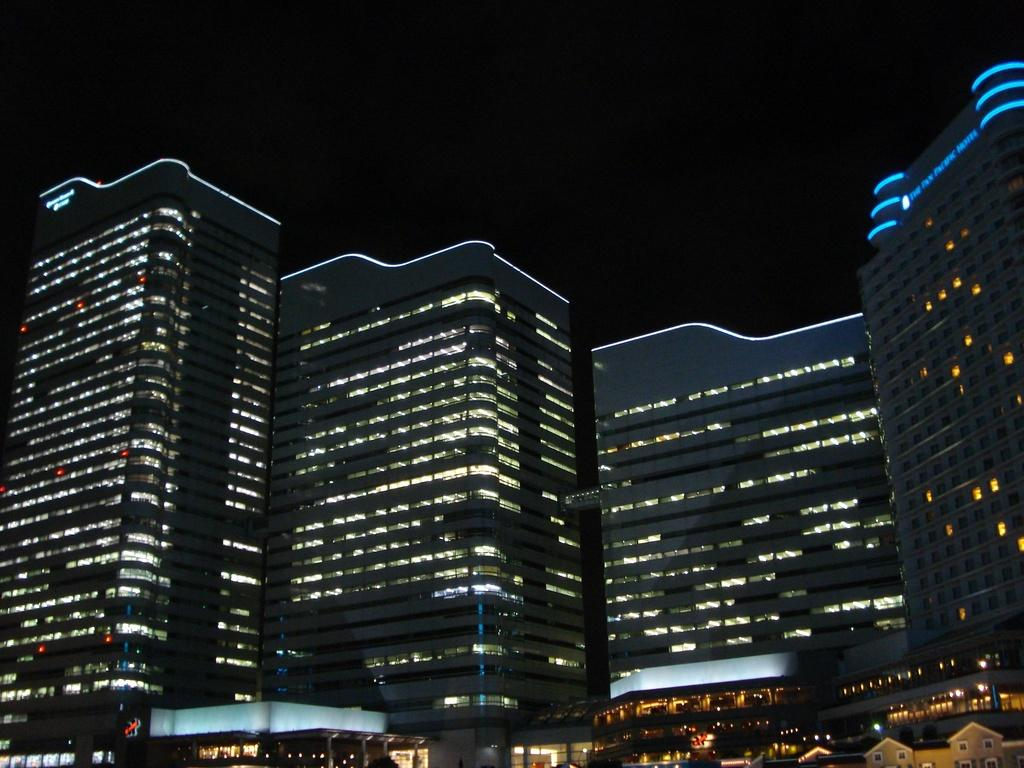What type of structures can be seen in the image? There are buildings in the image. Can you describe any specific features of the buildings? The buildings have lights inside them. What type of pump can be seen in the image? There is no pump present in the image; it only features buildings with lights inside them. 